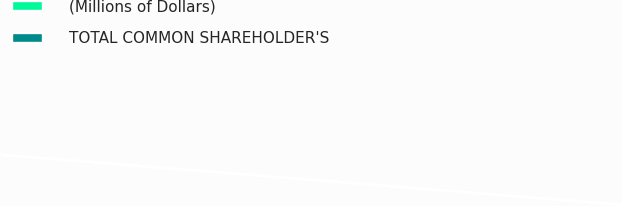Convert chart to OTSL. <chart><loc_0><loc_0><loc_500><loc_500><pie_chart><fcel>(Millions of Dollars)<fcel>TOTAL COMMON SHAREHOLDER'S<nl><fcel>0.0%<fcel>100.0%<nl></chart> 